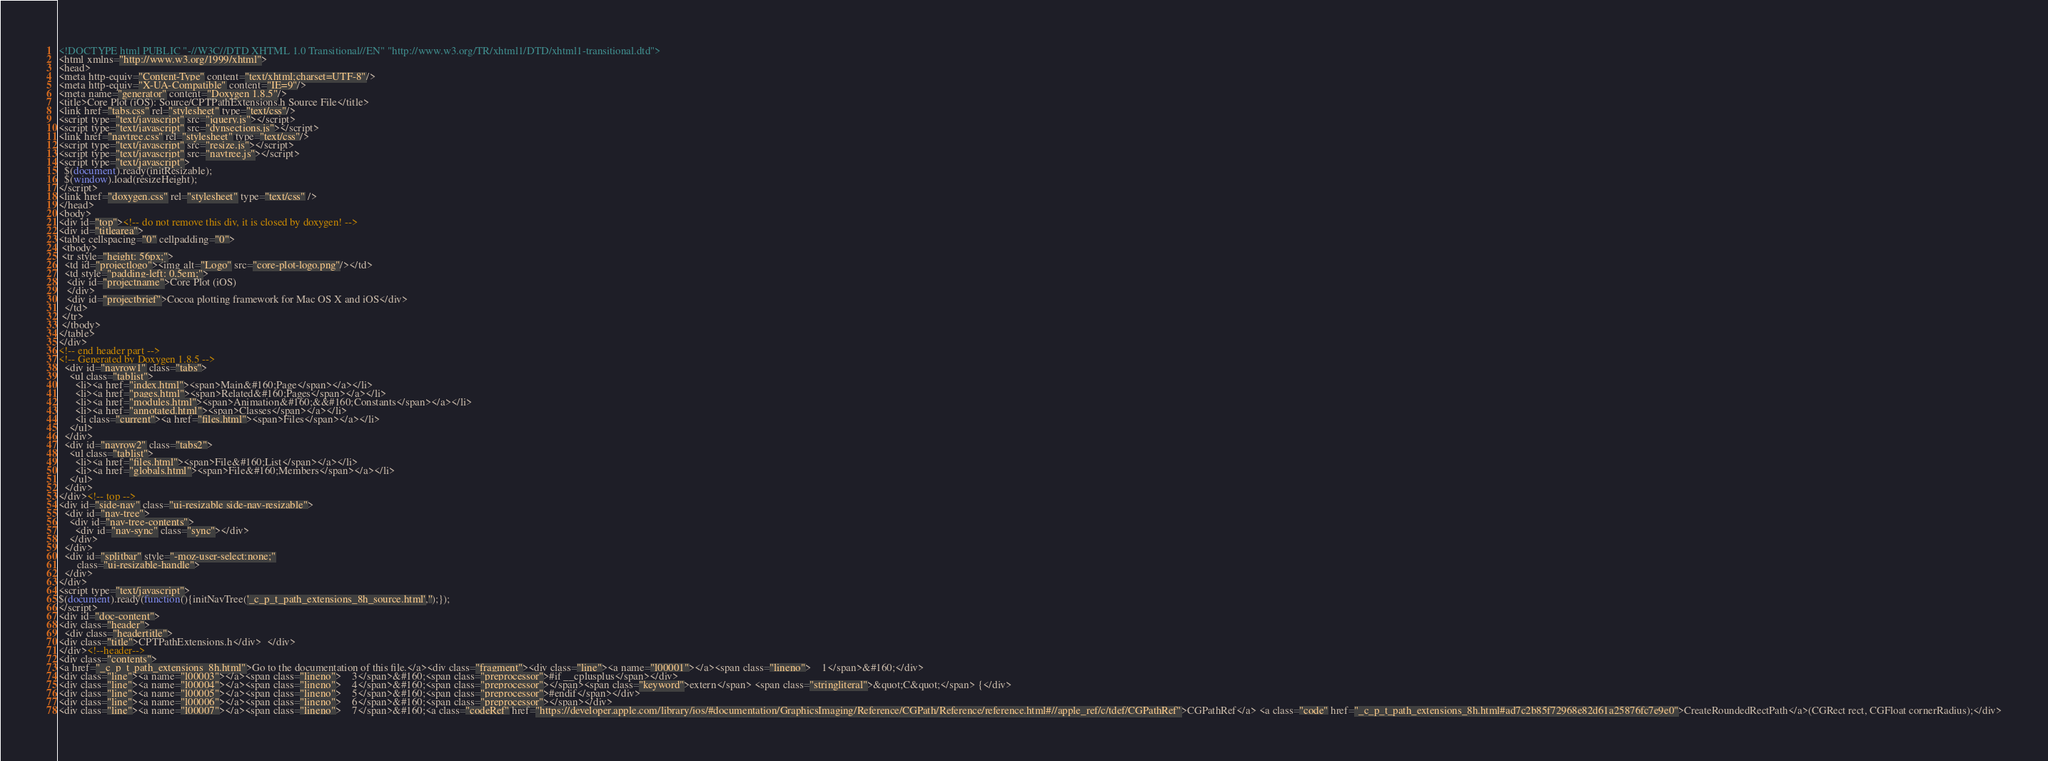Convert code to text. <code><loc_0><loc_0><loc_500><loc_500><_HTML_><!DOCTYPE html PUBLIC "-//W3C//DTD XHTML 1.0 Transitional//EN" "http://www.w3.org/TR/xhtml1/DTD/xhtml1-transitional.dtd">
<html xmlns="http://www.w3.org/1999/xhtml">
<head>
<meta http-equiv="Content-Type" content="text/xhtml;charset=UTF-8"/>
<meta http-equiv="X-UA-Compatible" content="IE=9"/>
<meta name="generator" content="Doxygen 1.8.5"/>
<title>Core Plot (iOS): Source/CPTPathExtensions.h Source File</title>
<link href="tabs.css" rel="stylesheet" type="text/css"/>
<script type="text/javascript" src="jquery.js"></script>
<script type="text/javascript" src="dynsections.js"></script>
<link href="navtree.css" rel="stylesheet" type="text/css"/>
<script type="text/javascript" src="resize.js"></script>
<script type="text/javascript" src="navtree.js"></script>
<script type="text/javascript">
  $(document).ready(initResizable);
  $(window).load(resizeHeight);
</script>
<link href="doxygen.css" rel="stylesheet" type="text/css" />
</head>
<body>
<div id="top"><!-- do not remove this div, it is closed by doxygen! -->
<div id="titlearea">
<table cellspacing="0" cellpadding="0">
 <tbody>
 <tr style="height: 56px;">
  <td id="projectlogo"><img alt="Logo" src="core-plot-logo.png"/></td>
  <td style="padding-left: 0.5em;">
   <div id="projectname">Core Plot (iOS)
   </div>
   <div id="projectbrief">Cocoa plotting framework for Mac OS X and iOS</div>
  </td>
 </tr>
 </tbody>
</table>
</div>
<!-- end header part -->
<!-- Generated by Doxygen 1.8.5 -->
  <div id="navrow1" class="tabs">
    <ul class="tablist">
      <li><a href="index.html"><span>Main&#160;Page</span></a></li>
      <li><a href="pages.html"><span>Related&#160;Pages</span></a></li>
      <li><a href="modules.html"><span>Animation&#160;&&#160;Constants</span></a></li>
      <li><a href="annotated.html"><span>Classes</span></a></li>
      <li class="current"><a href="files.html"><span>Files</span></a></li>
    </ul>
  </div>
  <div id="navrow2" class="tabs2">
    <ul class="tablist">
      <li><a href="files.html"><span>File&#160;List</span></a></li>
      <li><a href="globals.html"><span>File&#160;Members</span></a></li>
    </ul>
  </div>
</div><!-- top -->
<div id="side-nav" class="ui-resizable side-nav-resizable">
  <div id="nav-tree">
    <div id="nav-tree-contents">
      <div id="nav-sync" class="sync"></div>
    </div>
  </div>
  <div id="splitbar" style="-moz-user-select:none;" 
       class="ui-resizable-handle">
  </div>
</div>
<script type="text/javascript">
$(document).ready(function(){initNavTree('_c_p_t_path_extensions_8h_source.html','');});
</script>
<div id="doc-content">
<div class="header">
  <div class="headertitle">
<div class="title">CPTPathExtensions.h</div>  </div>
</div><!--header-->
<div class="contents">
<a href="_c_p_t_path_extensions_8h.html">Go to the documentation of this file.</a><div class="fragment"><div class="line"><a name="l00001"></a><span class="lineno">    1</span>&#160;</div>
<div class="line"><a name="l00003"></a><span class="lineno">    3</span>&#160;<span class="preprocessor">#if __cplusplus</span></div>
<div class="line"><a name="l00004"></a><span class="lineno">    4</span>&#160;<span class="preprocessor"></span><span class="keyword">extern</span> <span class="stringliteral">&quot;C&quot;</span> {</div>
<div class="line"><a name="l00005"></a><span class="lineno">    5</span>&#160;<span class="preprocessor">#endif</span></div>
<div class="line"><a name="l00006"></a><span class="lineno">    6</span>&#160;<span class="preprocessor"></span></div>
<div class="line"><a name="l00007"></a><span class="lineno">    7</span>&#160;<a class="codeRef" href="https://developer.apple.com/library/ios/#documentation/GraphicsImaging/Reference/CGPath/Reference/reference.html#//apple_ref/c/tdef/CGPathRef">CGPathRef</a> <a class="code" href="_c_p_t_path_extensions_8h.html#ad7c2b85f72968e82d61a25876fc7e9e0">CreateRoundedRectPath</a>(CGRect rect, CGFloat cornerRadius);</div></code> 